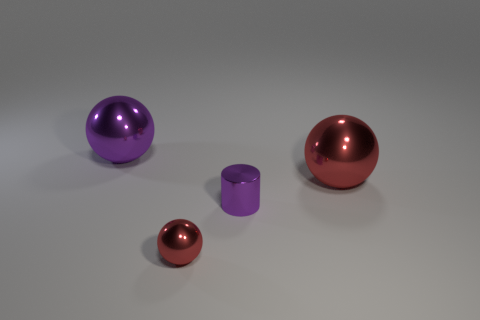Subtract all large red metallic balls. How many balls are left? 2 Subtract all red cubes. How many red balls are left? 2 Subtract 1 spheres. How many spheres are left? 2 Add 2 purple cylinders. How many objects exist? 6 Subtract all cylinders. How many objects are left? 3 Subtract 1 purple spheres. How many objects are left? 3 Subtract all big purple metal objects. Subtract all red objects. How many objects are left? 1 Add 1 small red metal balls. How many small red metal balls are left? 2 Add 1 tiny yellow balls. How many tiny yellow balls exist? 1 